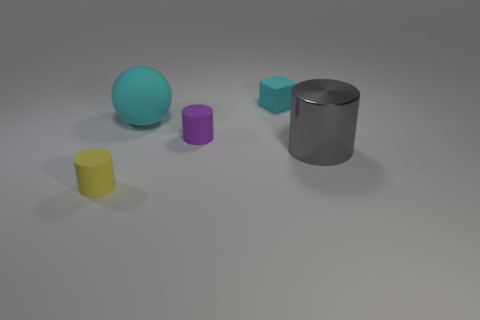The large object that is to the left of the cylinder to the right of the purple cylinder is what shape?
Offer a terse response. Sphere. Are there any other purple rubber objects that have the same shape as the large rubber object?
Offer a very short reply. No. What number of big rubber blocks are there?
Offer a very short reply. 0. Is the cylinder that is in front of the big gray cylinder made of the same material as the block?
Your response must be concise. Yes. Is there a block that has the same size as the yellow matte thing?
Give a very brief answer. Yes. There is a gray thing; is it the same shape as the large object to the left of the cube?
Provide a succinct answer. No. Are there any yellow rubber objects in front of the tiny rubber cylinder that is behind the small cylinder left of the purple object?
Ensure brevity in your answer.  Yes. How big is the yellow thing?
Provide a succinct answer. Small. How many other objects are there of the same color as the small matte block?
Offer a terse response. 1. There is a thing that is in front of the large gray thing; does it have the same shape as the small purple object?
Your response must be concise. Yes. 